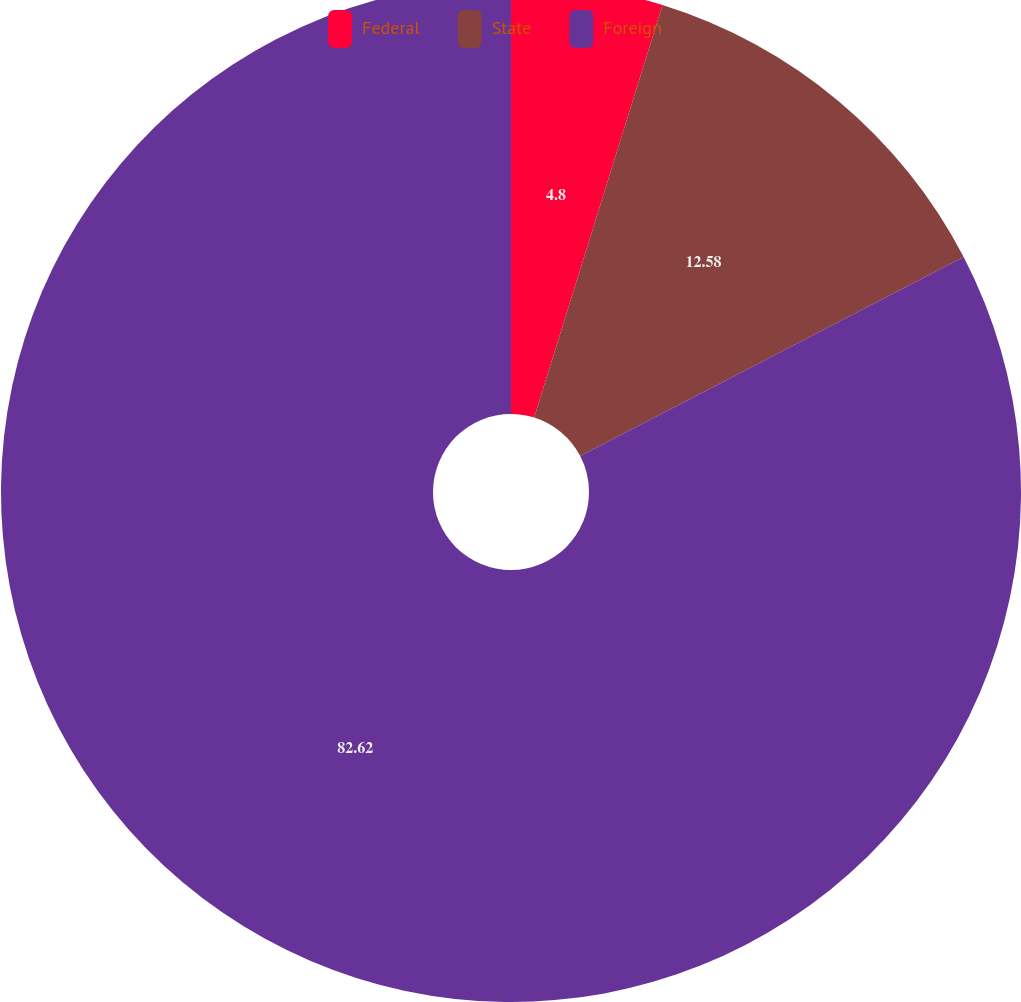Convert chart to OTSL. <chart><loc_0><loc_0><loc_500><loc_500><pie_chart><fcel>Federal<fcel>State<fcel>Foreign<nl><fcel>4.8%<fcel>12.58%<fcel>82.61%<nl></chart> 